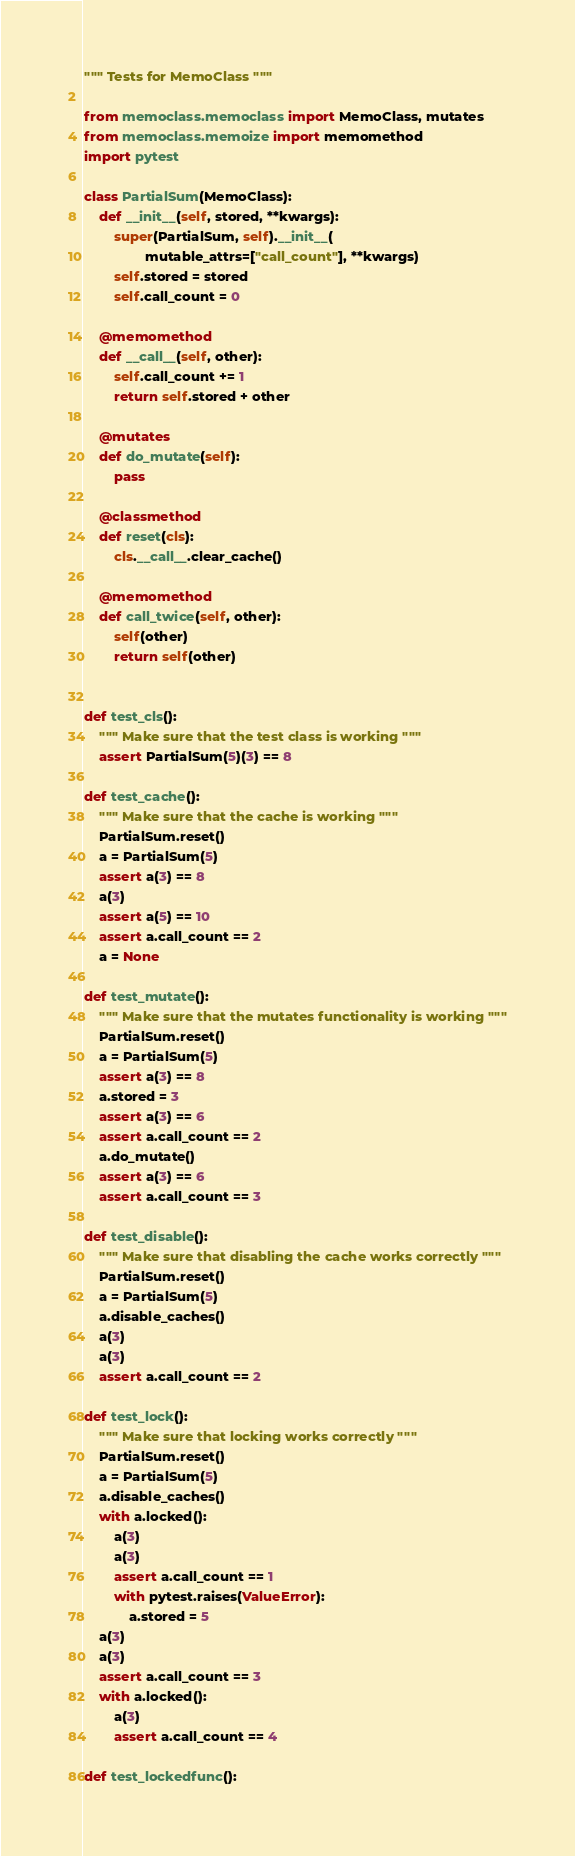<code> <loc_0><loc_0><loc_500><loc_500><_Python_>""" Tests for MemoClass """

from memoclass.memoclass import MemoClass, mutates
from memoclass.memoize import memomethod
import pytest

class PartialSum(MemoClass):
    def __init__(self, stored, **kwargs):
        super(PartialSum, self).__init__(
                mutable_attrs=["call_count"], **kwargs)
        self.stored = stored
        self.call_count = 0

    @memomethod
    def __call__(self, other):
        self.call_count += 1
        return self.stored + other

    @mutates
    def do_mutate(self):
        pass

    @classmethod
    def reset(cls):
        cls.__call__.clear_cache()

    @memomethod
    def call_twice(self, other):
        self(other)
        return self(other)


def test_cls():
    """ Make sure that the test class is working """
    assert PartialSum(5)(3) == 8

def test_cache():
    """ Make sure that the cache is working """
    PartialSum.reset()
    a = PartialSum(5)
    assert a(3) == 8
    a(3)
    assert a(5) == 10
    assert a.call_count == 2
    a = None

def test_mutate():
    """ Make sure that the mutates functionality is working """
    PartialSum.reset()
    a = PartialSum(5)
    assert a(3) == 8
    a.stored = 3
    assert a(3) == 6
    assert a.call_count == 2
    a.do_mutate()
    assert a(3) == 6
    assert a.call_count == 3

def test_disable():
    """ Make sure that disabling the cache works correctly """
    PartialSum.reset()
    a = PartialSum(5)
    a.disable_caches()
    a(3)
    a(3)
    assert a.call_count == 2

def test_lock():
    """ Make sure that locking works correctly """
    PartialSum.reset()
    a = PartialSum(5)
    a.disable_caches()
    with a.locked():
        a(3)
        a(3)
        assert a.call_count == 1
        with pytest.raises(ValueError):
            a.stored = 5
    a(3)
    a(3)
    assert a.call_count == 3
    with a.locked():
        a(3)
        assert a.call_count == 4

def test_lockedfunc():</code> 